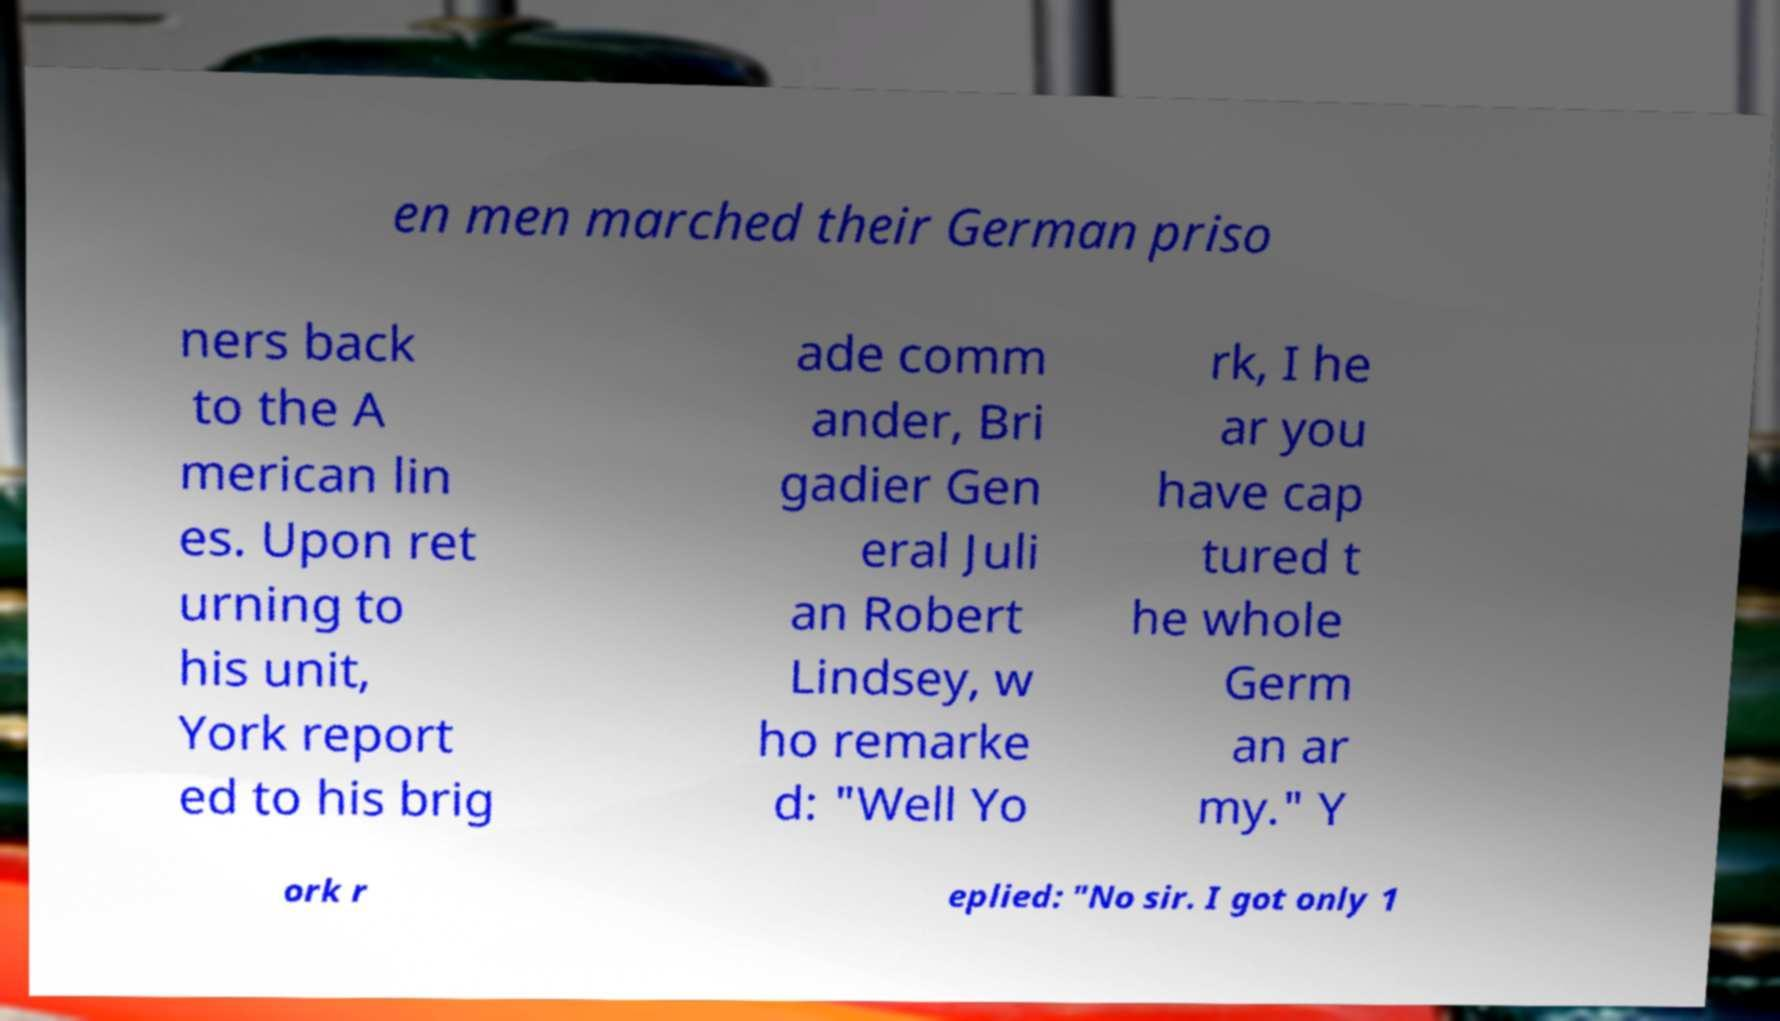Could you extract and type out the text from this image? en men marched their German priso ners back to the A merican lin es. Upon ret urning to his unit, York report ed to his brig ade comm ander, Bri gadier Gen eral Juli an Robert Lindsey, w ho remarke d: "Well Yo rk, I he ar you have cap tured t he whole Germ an ar my." Y ork r eplied: "No sir. I got only 1 